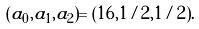<formula> <loc_0><loc_0><loc_500><loc_500>( a _ { 0 } , a _ { 1 } , a _ { 2 } ) = ( 1 6 , 1 / 2 , 1 / 2 ) .</formula> 